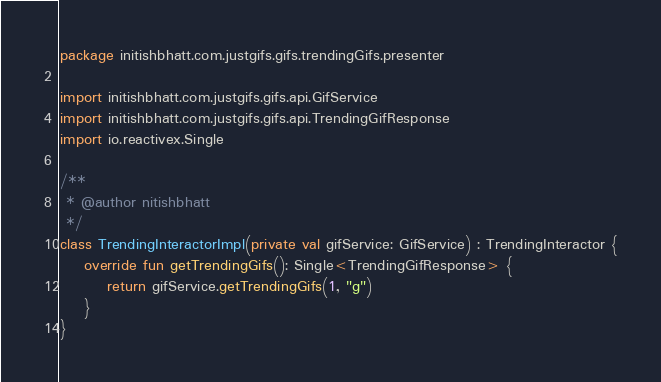Convert code to text. <code><loc_0><loc_0><loc_500><loc_500><_Kotlin_>package initishbhatt.com.justgifs.gifs.trendingGifs.presenter

import initishbhatt.com.justgifs.gifs.api.GifService
import initishbhatt.com.justgifs.gifs.api.TrendingGifResponse
import io.reactivex.Single

/**
 * @author nitishbhatt
 */
class TrendingInteractorImpl(private val gifService: GifService) : TrendingInteractor {
    override fun getTrendingGifs(): Single<TrendingGifResponse> {
        return gifService.getTrendingGifs(1, "g")
    }
}</code> 